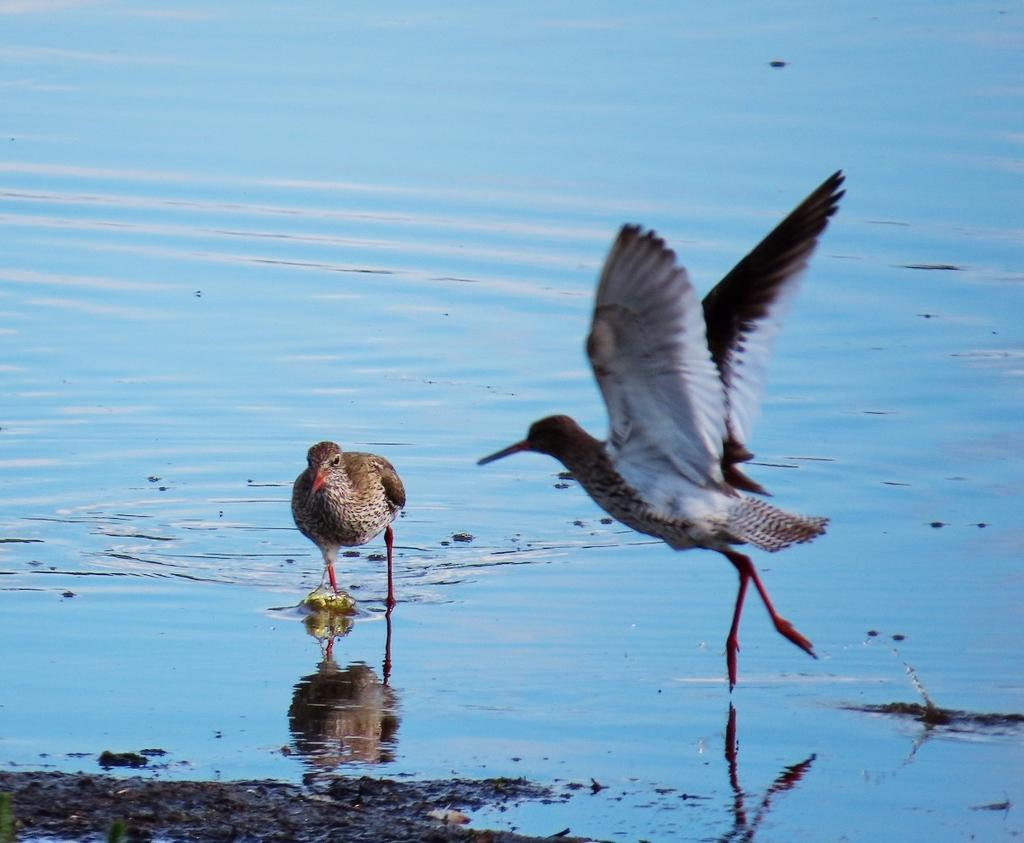What are the main subjects in the center of the image? There are two cranes in the center of the image. What can be seen at the bottom of the image? There is a lake and sand at the bottom of the image. What type of meal is being prepared by the cranes in the image? There is no meal being prepared in the image; the cranes are not involved in any food-related activity. 